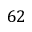Convert formula to latex. <formula><loc_0><loc_0><loc_500><loc_500>6 2</formula> 